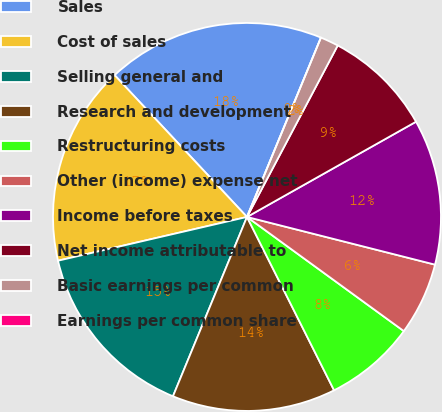Convert chart to OTSL. <chart><loc_0><loc_0><loc_500><loc_500><pie_chart><fcel>Sales<fcel>Cost of sales<fcel>Selling general and<fcel>Research and development<fcel>Restructuring costs<fcel>Other (income) expense net<fcel>Income before taxes<fcel>Net income attributable to<fcel>Basic earnings per common<fcel>Earnings per common share<nl><fcel>18.18%<fcel>16.67%<fcel>15.15%<fcel>13.64%<fcel>7.58%<fcel>6.06%<fcel>12.12%<fcel>9.09%<fcel>1.52%<fcel>0.0%<nl></chart> 